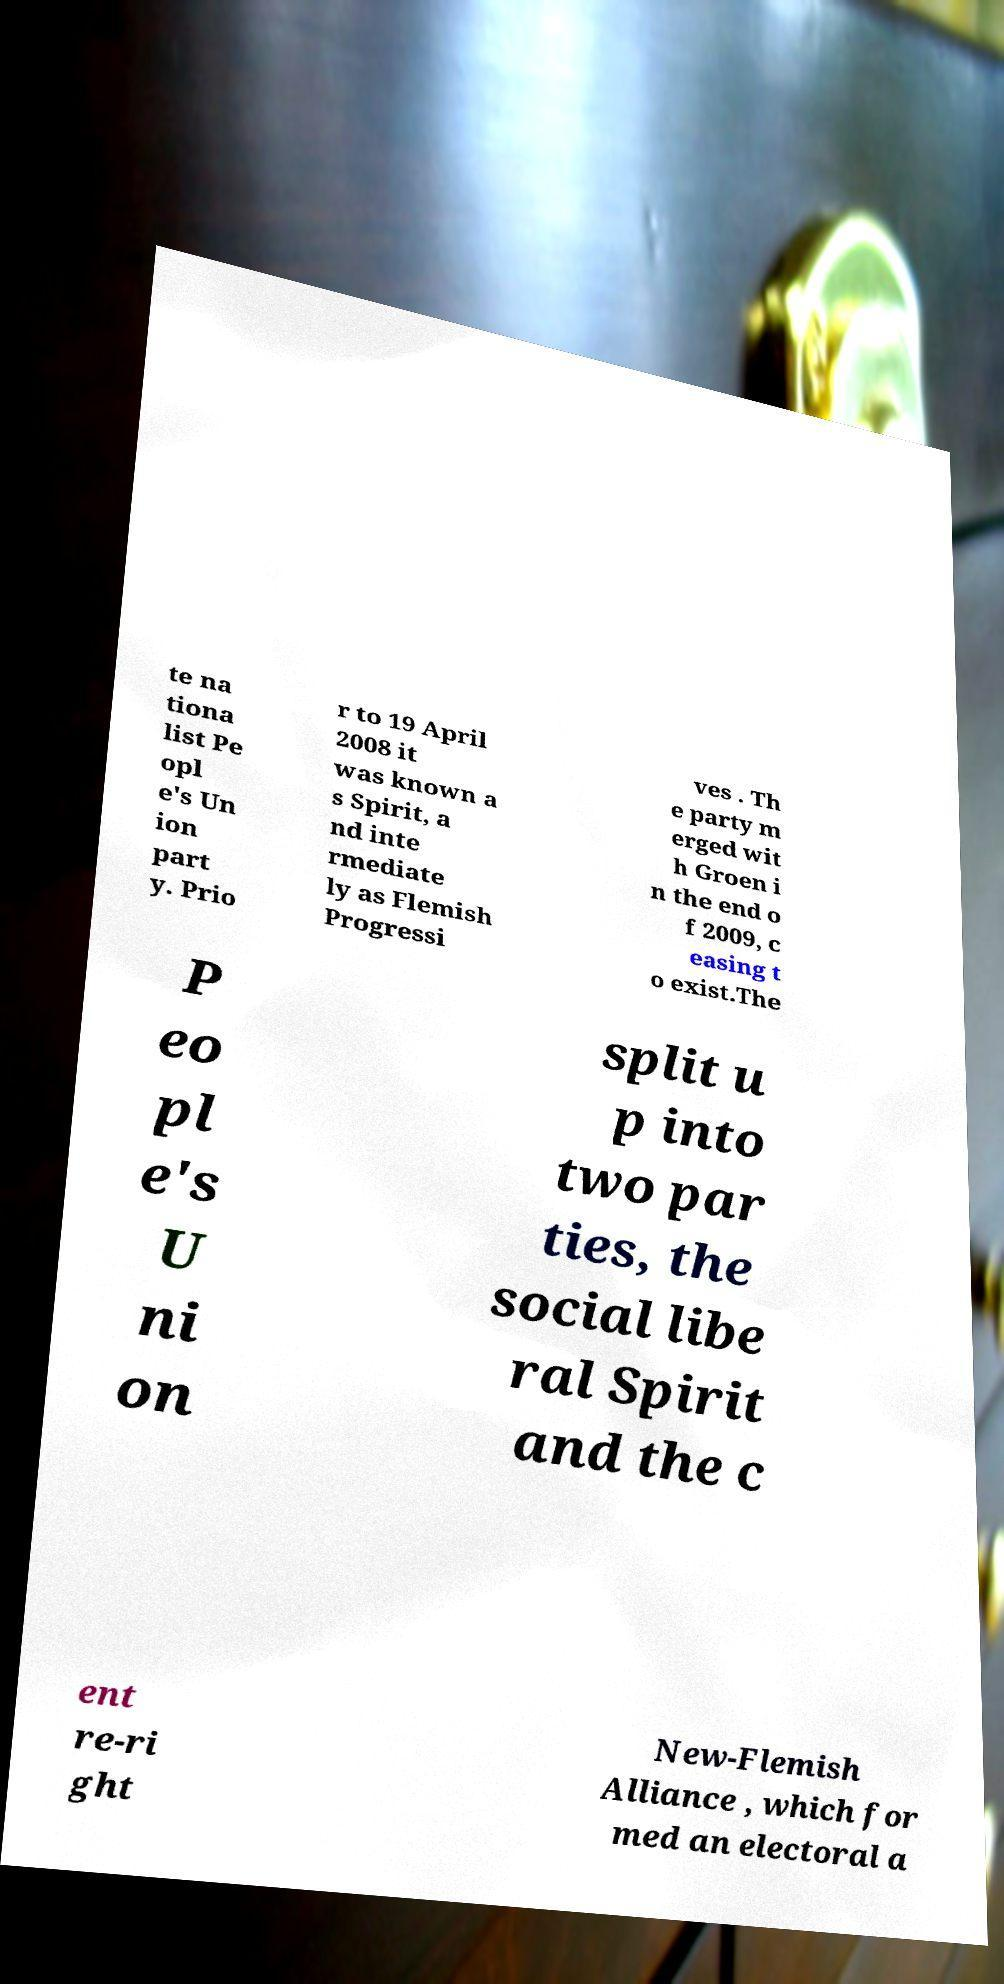Please read and relay the text visible in this image. What does it say? te na tiona list Pe opl e's Un ion part y. Prio r to 19 April 2008 it was known a s Spirit, a nd inte rmediate ly as Flemish Progressi ves . Th e party m erged wit h Groen i n the end o f 2009, c easing t o exist.The P eo pl e's U ni on split u p into two par ties, the social libe ral Spirit and the c ent re-ri ght New-Flemish Alliance , which for med an electoral a 